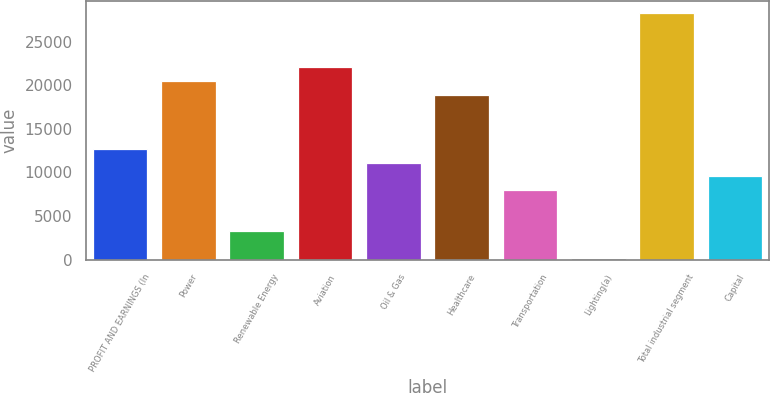Convert chart to OTSL. <chart><loc_0><loc_0><loc_500><loc_500><bar_chart><fcel>PROFIT AND EARNINGS (In<fcel>Power<fcel>Renewable Energy<fcel>Aviation<fcel>Oil & Gas<fcel>Healthcare<fcel>Transportation<fcel>Lighting(a)<fcel>Total industrial segment<fcel>Capital<nl><fcel>12661<fcel>20471<fcel>3289<fcel>22033<fcel>11099<fcel>18909<fcel>7975<fcel>165<fcel>28281<fcel>9537<nl></chart> 